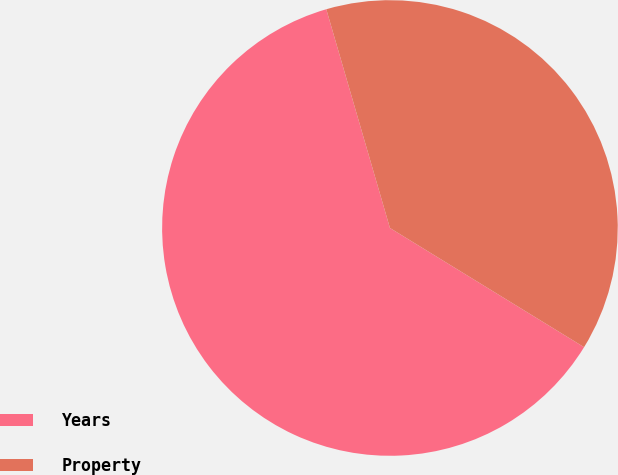<chart> <loc_0><loc_0><loc_500><loc_500><pie_chart><fcel>Years<fcel>Property<nl><fcel>61.73%<fcel>38.27%<nl></chart> 